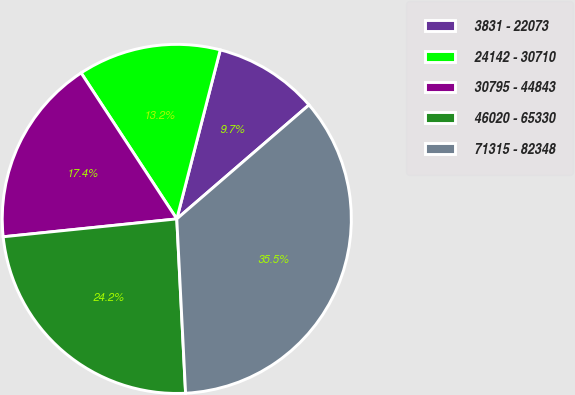Convert chart. <chart><loc_0><loc_0><loc_500><loc_500><pie_chart><fcel>3831 - 22073<fcel>24142 - 30710<fcel>30795 - 44843<fcel>46020 - 65330<fcel>71315 - 82348<nl><fcel>9.67%<fcel>13.24%<fcel>17.4%<fcel>24.17%<fcel>35.52%<nl></chart> 